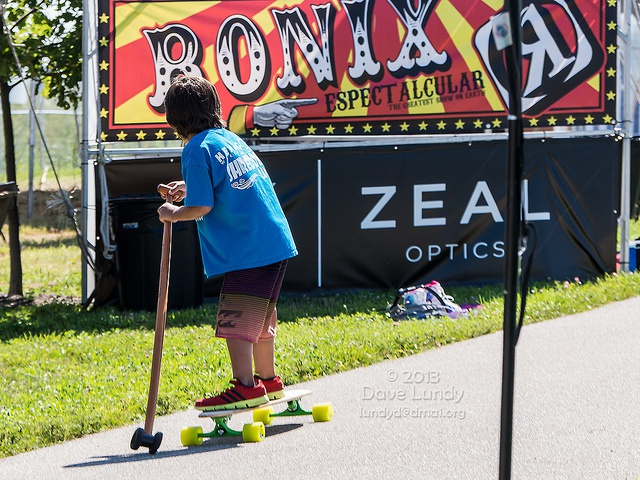Describe the objects in this image and their specific colors. I can see people in gray, blue, black, brown, and maroon tones, skateboard in gray, lightgray, olive, darkgreen, and gold tones, and backpack in gray, lavender, black, darkgray, and blue tones in this image. 